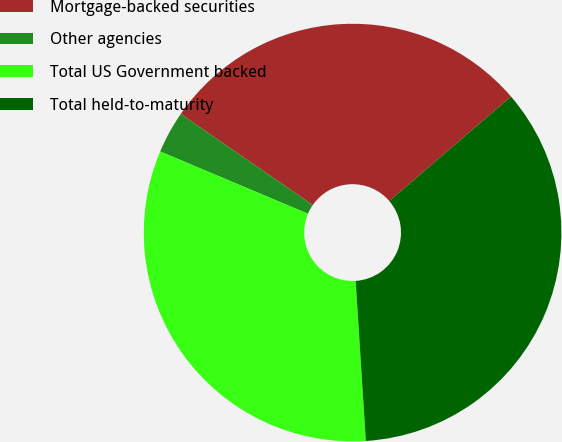Convert chart. <chart><loc_0><loc_0><loc_500><loc_500><pie_chart><fcel>Mortgage-backed securities<fcel>Other agencies<fcel>Total US Government backed<fcel>Total held-to-maturity<nl><fcel>29.09%<fcel>3.27%<fcel>32.36%<fcel>35.28%<nl></chart> 